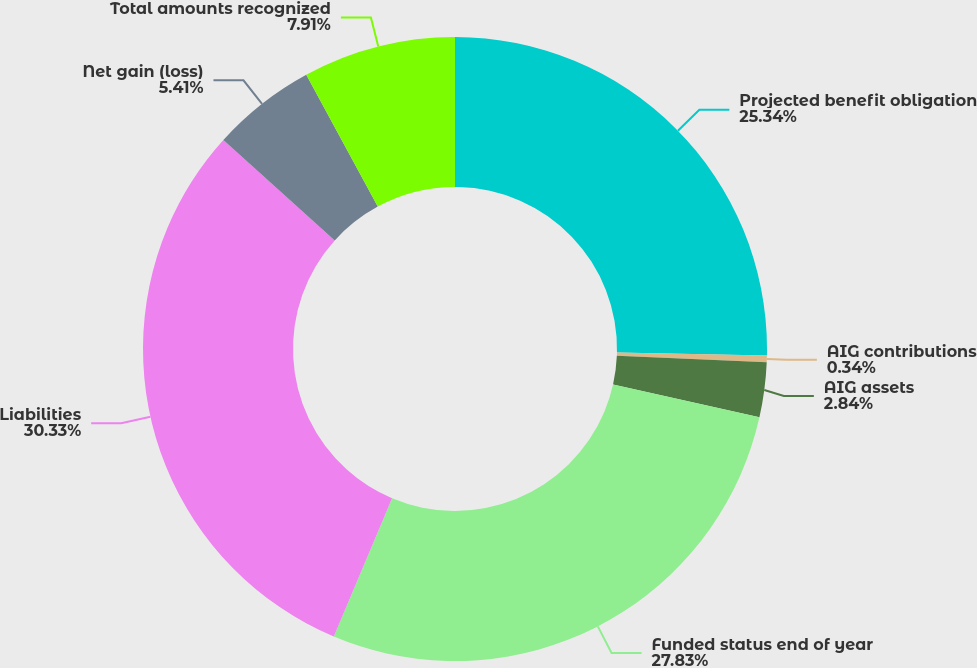<chart> <loc_0><loc_0><loc_500><loc_500><pie_chart><fcel>Projected benefit obligation<fcel>AIG contributions<fcel>AIG assets<fcel>Funded status end of year<fcel>Liabilities<fcel>Net gain (loss)<fcel>Total amounts recognized<nl><fcel>25.34%<fcel>0.34%<fcel>2.84%<fcel>27.84%<fcel>30.34%<fcel>5.41%<fcel>7.91%<nl></chart> 